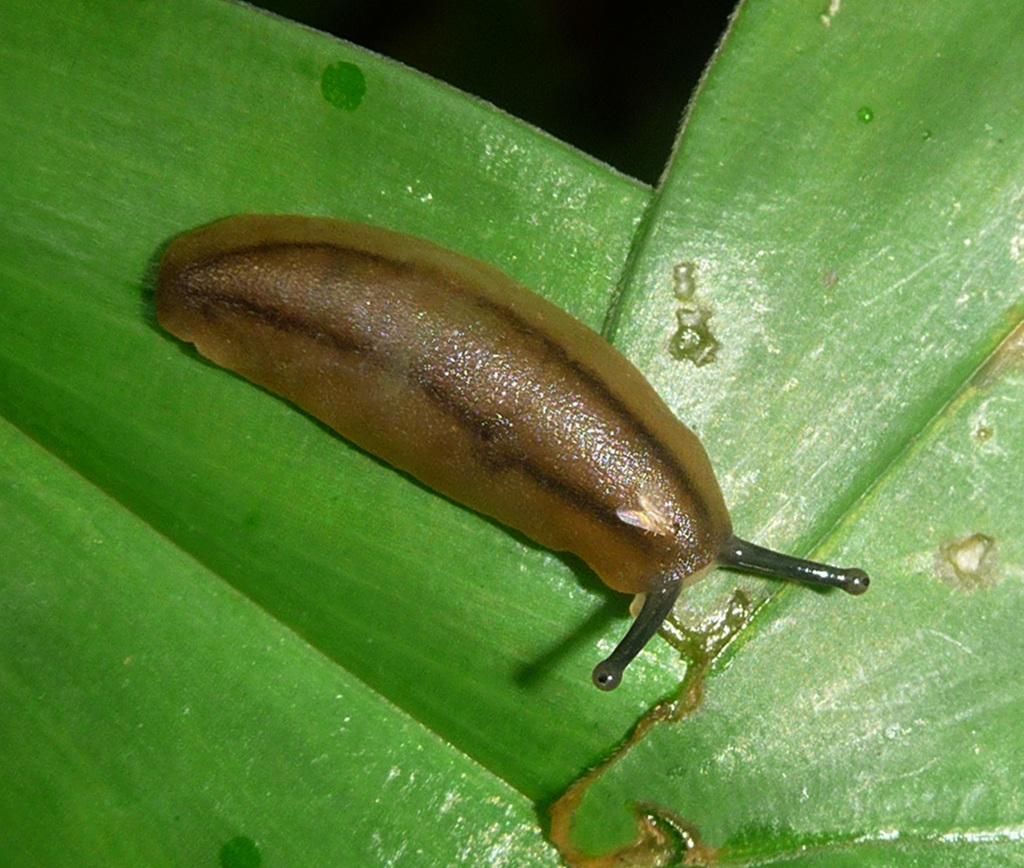Can you describe this image briefly? In this image, we can see a snail on the green leaf. Here we can see a black color. 